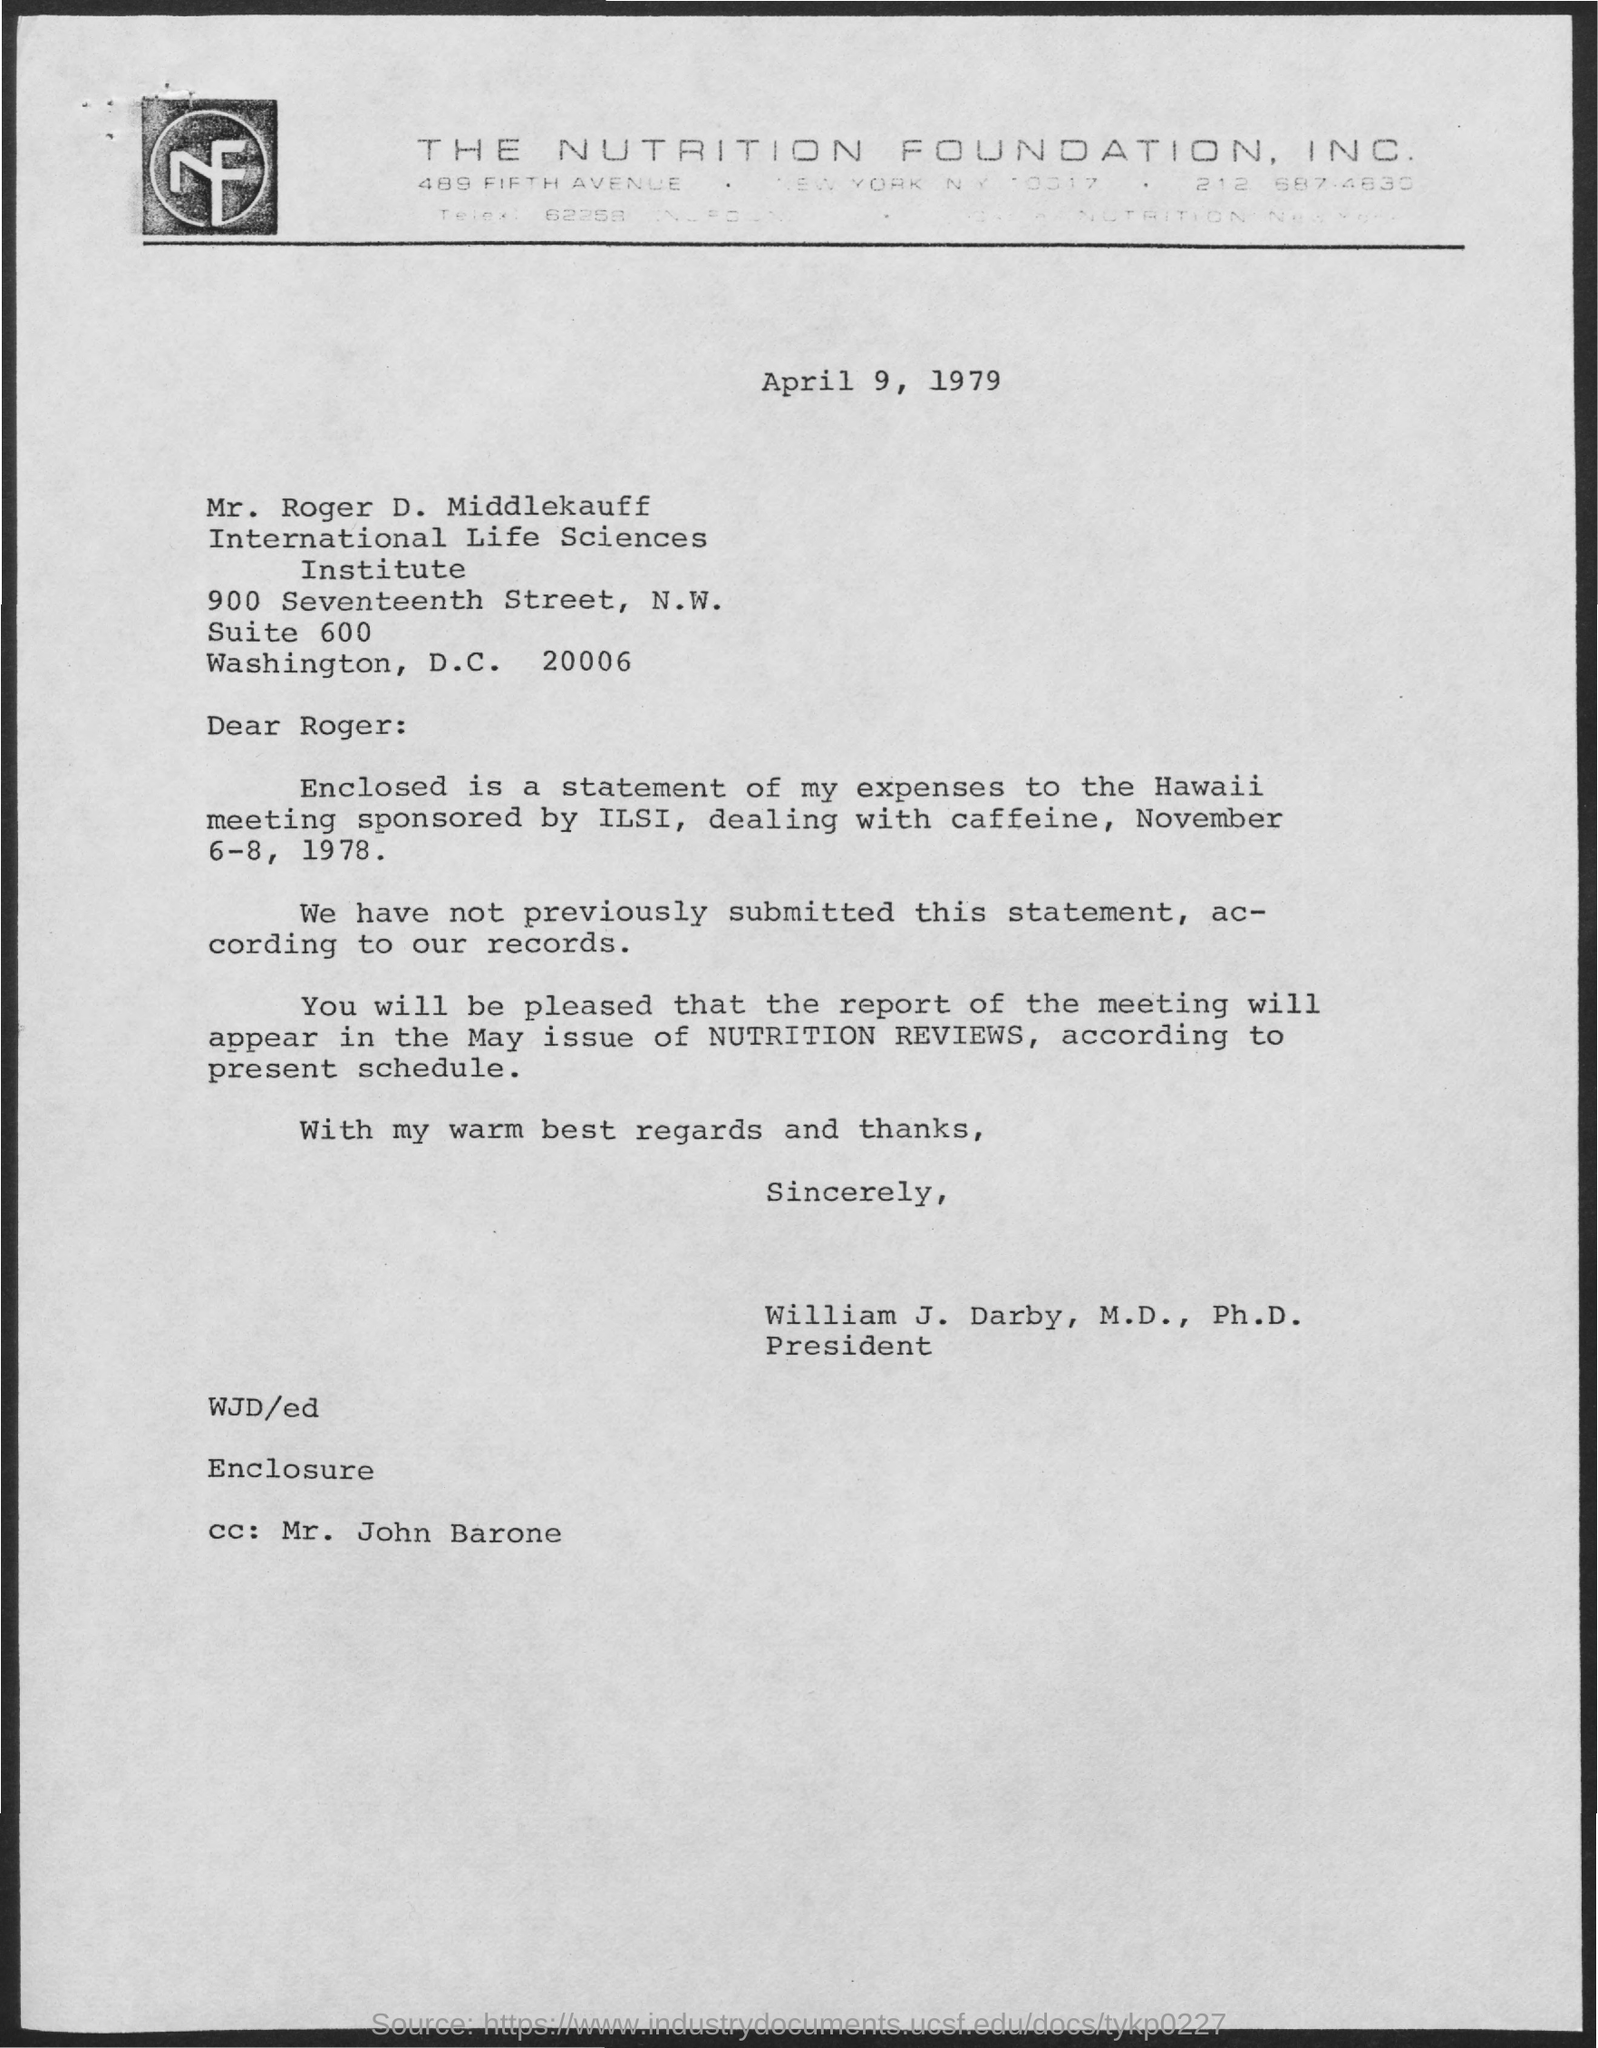What is the date on the document?
Provide a succinct answer. April 9, 1979. To Whom is this letter addressed to?
Your response must be concise. Mr. Roger D. Middlekauff. Where will the report of the meeting appear?
Your response must be concise. May issue of Nutrition Reviews. Who is this letter from?
Offer a very short reply. William J. Darby, M.D., Ph.D. 